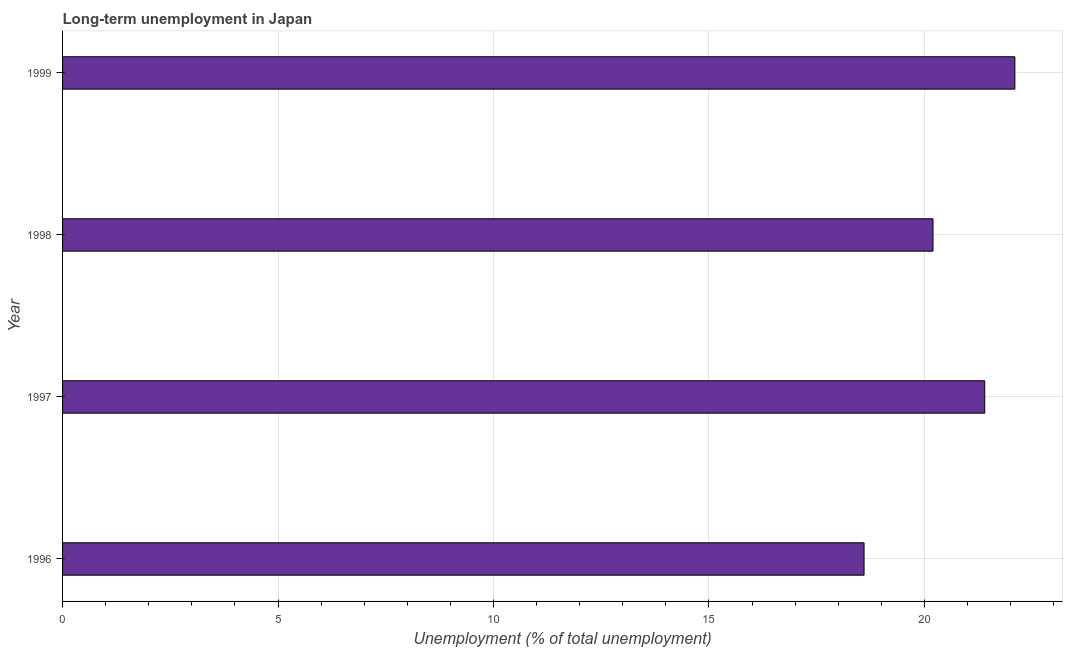Does the graph contain grids?
Provide a short and direct response. Yes. What is the title of the graph?
Your answer should be very brief. Long-term unemployment in Japan. What is the label or title of the X-axis?
Your answer should be compact. Unemployment (% of total unemployment). What is the long-term unemployment in 1997?
Your response must be concise. 21.4. Across all years, what is the maximum long-term unemployment?
Offer a very short reply. 22.1. Across all years, what is the minimum long-term unemployment?
Ensure brevity in your answer.  18.6. What is the sum of the long-term unemployment?
Your response must be concise. 82.3. What is the average long-term unemployment per year?
Give a very brief answer. 20.57. What is the median long-term unemployment?
Your answer should be compact. 20.8. Do a majority of the years between 1999 and 1998 (inclusive) have long-term unemployment greater than 13 %?
Make the answer very short. No. What is the ratio of the long-term unemployment in 1997 to that in 1999?
Your answer should be compact. 0.97. Is the difference between the long-term unemployment in 1997 and 1998 greater than the difference between any two years?
Give a very brief answer. No. What is the difference between the highest and the second highest long-term unemployment?
Provide a succinct answer. 0.7. Is the sum of the long-term unemployment in 1996 and 1999 greater than the maximum long-term unemployment across all years?
Your answer should be very brief. Yes. How many bars are there?
Your answer should be compact. 4. Are the values on the major ticks of X-axis written in scientific E-notation?
Ensure brevity in your answer.  No. What is the Unemployment (% of total unemployment) in 1996?
Ensure brevity in your answer.  18.6. What is the Unemployment (% of total unemployment) of 1997?
Provide a short and direct response. 21.4. What is the Unemployment (% of total unemployment) in 1998?
Ensure brevity in your answer.  20.2. What is the Unemployment (% of total unemployment) in 1999?
Ensure brevity in your answer.  22.1. What is the difference between the Unemployment (% of total unemployment) in 1996 and 1998?
Give a very brief answer. -1.6. What is the difference between the Unemployment (% of total unemployment) in 1996 and 1999?
Provide a short and direct response. -3.5. What is the difference between the Unemployment (% of total unemployment) in 1997 and 1998?
Provide a short and direct response. 1.2. What is the difference between the Unemployment (% of total unemployment) in 1998 and 1999?
Your answer should be compact. -1.9. What is the ratio of the Unemployment (% of total unemployment) in 1996 to that in 1997?
Your response must be concise. 0.87. What is the ratio of the Unemployment (% of total unemployment) in 1996 to that in 1998?
Ensure brevity in your answer.  0.92. What is the ratio of the Unemployment (% of total unemployment) in 1996 to that in 1999?
Offer a very short reply. 0.84. What is the ratio of the Unemployment (% of total unemployment) in 1997 to that in 1998?
Ensure brevity in your answer.  1.06. What is the ratio of the Unemployment (% of total unemployment) in 1997 to that in 1999?
Keep it short and to the point. 0.97. What is the ratio of the Unemployment (% of total unemployment) in 1998 to that in 1999?
Make the answer very short. 0.91. 